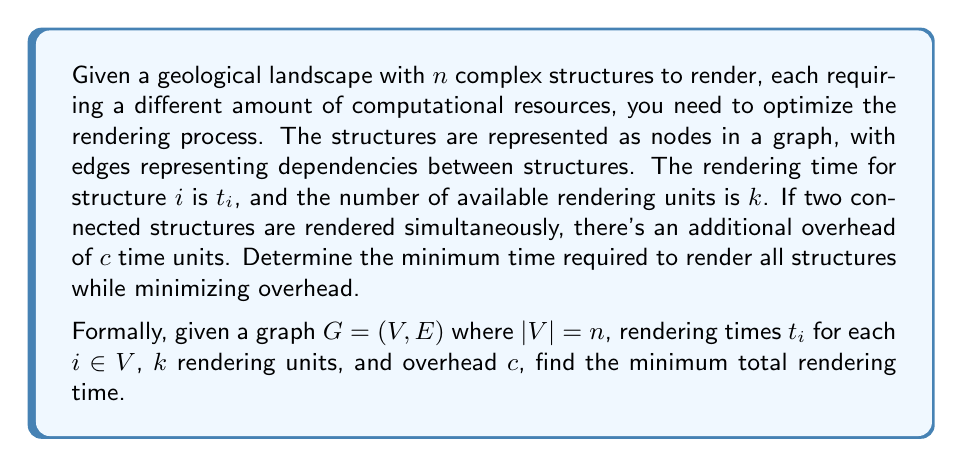Show me your answer to this math problem. To solve this problem, we can use a combination of graph theory and scheduling algorithms:

1. First, we need to find the critical path in the dependency graph. This can be done using a topological sort followed by a longest path algorithm.

2. Let $CP$ be the set of nodes in the critical path. The minimum possible rendering time is:

   $$T_{min} = \sum_{i \in CP} t_i$$

3. However, this doesn't account for the overhead or the limited rendering units. We need to create a schedule that minimizes overhead while respecting the $k$ unit constraint.

4. We can use a list scheduling algorithm with the following priority:
   a. Nodes in the critical path
   b. Nodes with the longest rendering time
   c. Nodes with the most dependencies

5. For each time step in the schedule:
   a. Assign available nodes to free rendering units
   b. If two connected nodes are rendered simultaneously, add $c$ to the total time
   c. Update the remaining rendering time for each assigned node

6. The total rendering time will be:

   $$T_{total} = T_{min} + T_{overhead} + T_{idle}$$

   Where $T_{overhead}$ is the total added overhead time, and $T_{idle}$ is the idle time due to resource constraints.

7. The exact solution to this problem is NP-hard, but this heuristic approach provides a good approximation.

To illustrate, let's consider a small example:
[asy]
unitsize(1cm);
pair[] v = {(0,0), (2,0), (1,1.5), (3,1.5), (4,0)};
for(int i=0; i<5; ++i) dot(v[i]);
draw(v[0]--v[1]--v[2]--v[3]--v[4]);
draw(v[0]--v[2]--v[4]);
label("1", v[0], SW);
label("2", v[1], SE);
label("3", v[2], N);
label("4", v[3], N);
label("5", v[4], SE);
[/asy]

With $t_1=3$, $t_2=2$, $t_3=4$, $t_4=3$, $t_5=2$, $k=2$, and $c=1$.

The critical path is 1-3-5, with $T_{min} = 3+4+2 = 9$.

A possible schedule:
- Time 0-2: Render 1 and 2
- Time 2-3: Render 1 and 5
- Time 3-7: Render 3 and 4
- Time 7-9: Render 5

Total time: 9 + 1 (overhead) = 10 time units.
Answer: The minimum total rendering time for the given example is 10 time units. 